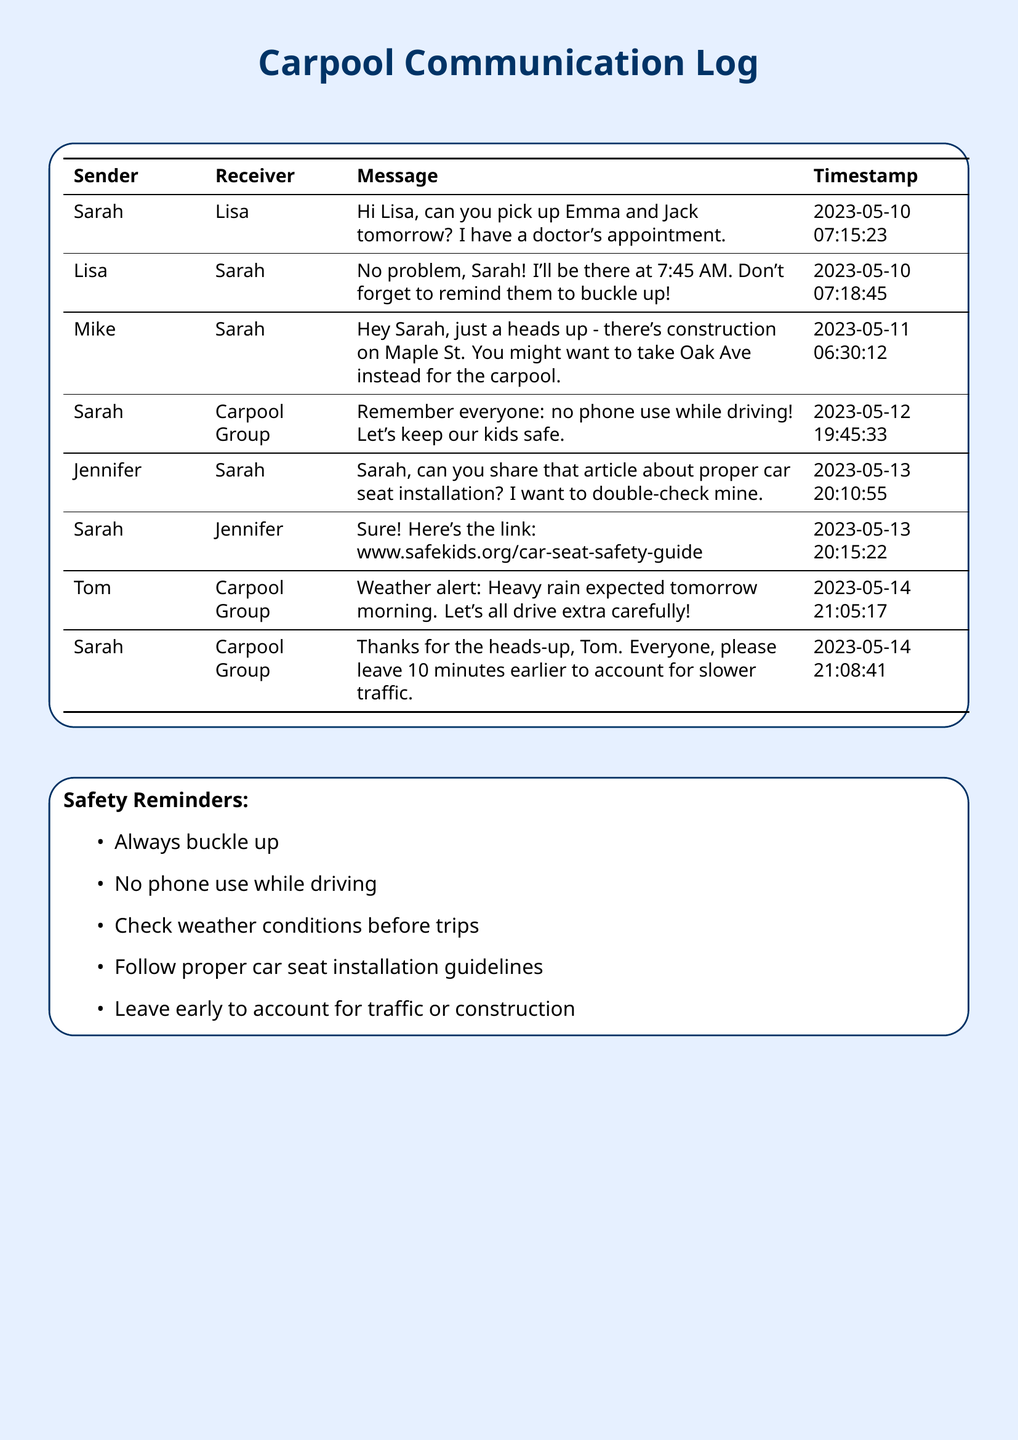What time will Lisa pick up the kids? Lisa mentioned she would be there at 7:45 AM to pick up Emma and Jack.
Answer: 7:45 AM Who asked for the article on car seat installation? Jennifer requested Sarah to share the article about proper car seat installation.
Answer: Jennifer What should parents not do while driving? Sarah reminded the carpool group that no phone use while driving is allowed for safety.
Answer: No phone use What is the weather alert about? Tom informed the carpool group about heavy rain expected the following morning, prompting them to drive carefully.
Answer: Heavy rain What resource did Sarah share about car seat safety? Sarah shared a link to Safe Kids regarding proper car seat installation.
Answer: www.safekids.org/car-seat-safety-guide How many minutes earlier does Sarah suggest to leave? To account for slower traffic, Sarah advised everyone to leave 10 minutes earlier.
Answer: 10 minutes What is one of the safety reminders? One of the important safety reminders is always to buckle up while driving.
Answer: Always buckle up When was the last message sent? The last recorded message in the log is on May 14, regarding the weather alert.
Answer: 2023-05-14 